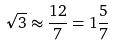<formula> <loc_0><loc_0><loc_500><loc_500>\sqrt { 3 } \approx \frac { 1 2 } { 7 } = 1 \frac { 5 } { 7 }</formula> 